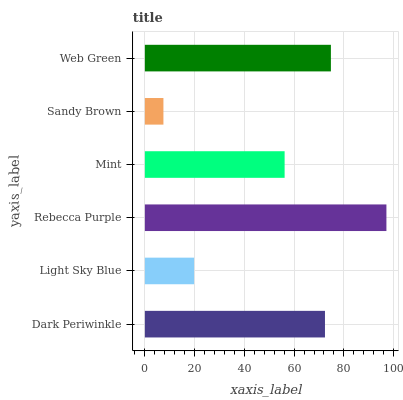Is Sandy Brown the minimum?
Answer yes or no. Yes. Is Rebecca Purple the maximum?
Answer yes or no. Yes. Is Light Sky Blue the minimum?
Answer yes or no. No. Is Light Sky Blue the maximum?
Answer yes or no. No. Is Dark Periwinkle greater than Light Sky Blue?
Answer yes or no. Yes. Is Light Sky Blue less than Dark Periwinkle?
Answer yes or no. Yes. Is Light Sky Blue greater than Dark Periwinkle?
Answer yes or no. No. Is Dark Periwinkle less than Light Sky Blue?
Answer yes or no. No. Is Dark Periwinkle the high median?
Answer yes or no. Yes. Is Mint the low median?
Answer yes or no. Yes. Is Web Green the high median?
Answer yes or no. No. Is Sandy Brown the low median?
Answer yes or no. No. 